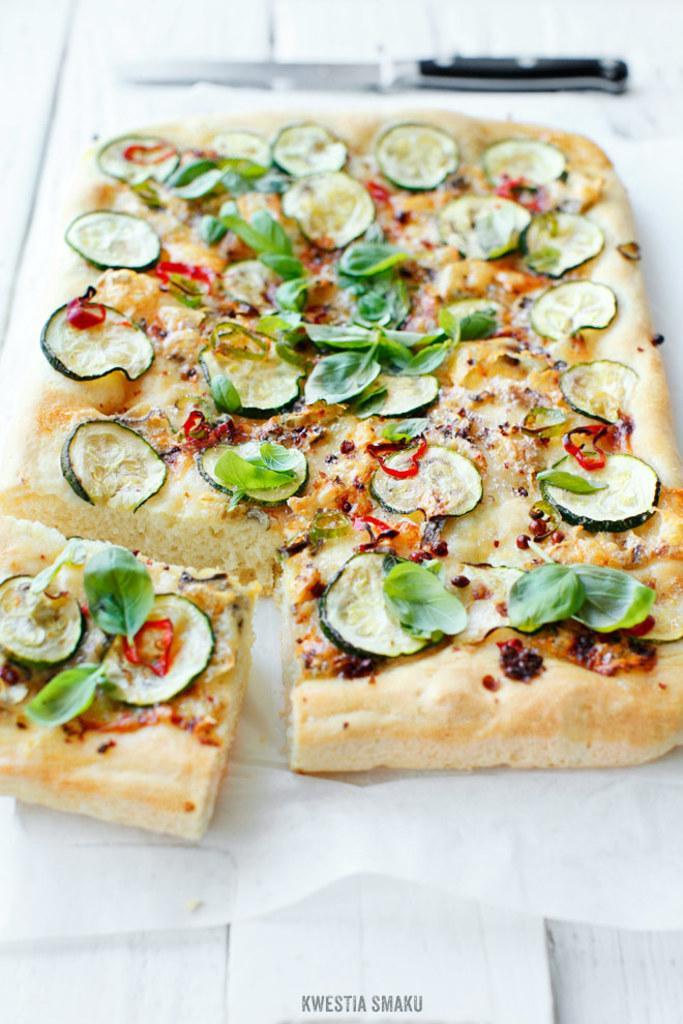In one or two sentences, can you explain what this image depicts? In the picture we can see some food item which is in plate. 